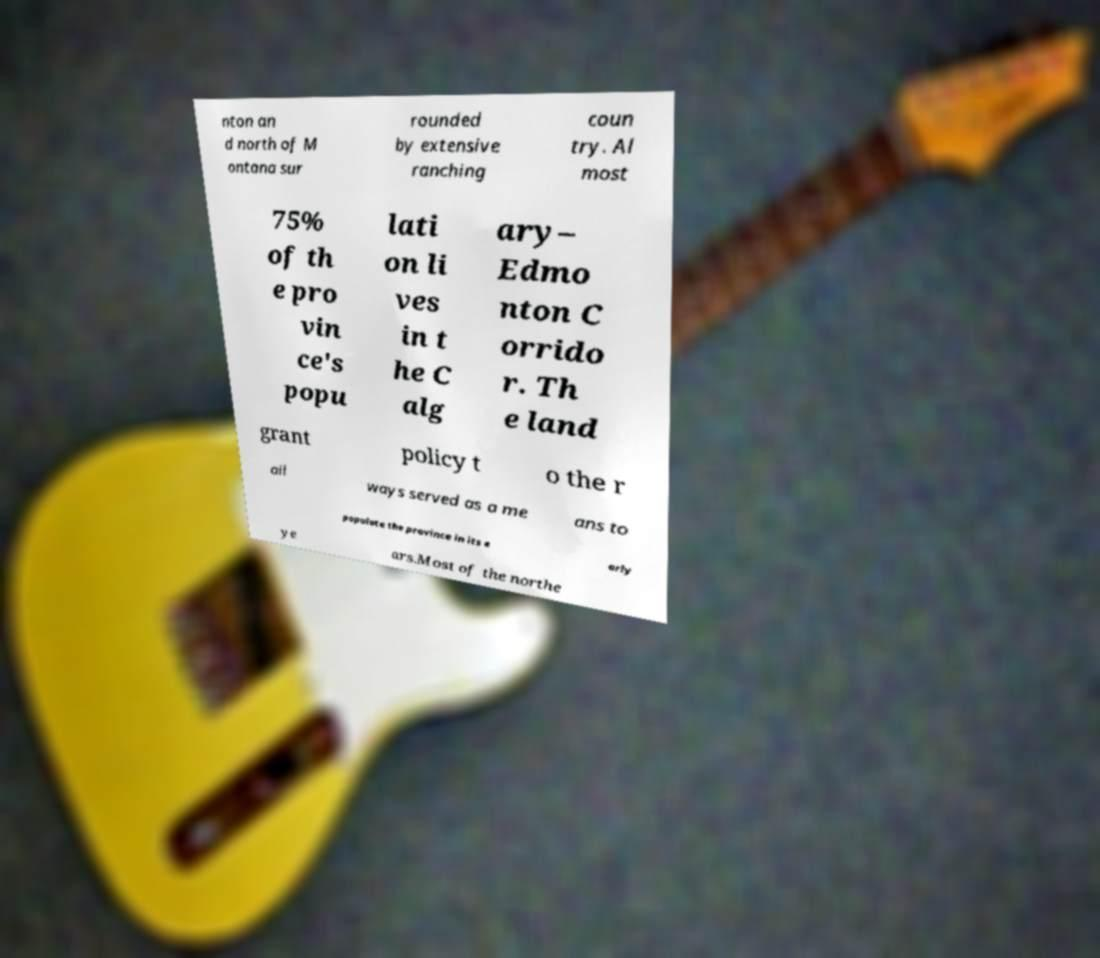For documentation purposes, I need the text within this image transcribed. Could you provide that? nton an d north of M ontana sur rounded by extensive ranching coun try. Al most 75% of th e pro vin ce's popu lati on li ves in t he C alg ary– Edmo nton C orrido r. Th e land grant policy t o the r ail ways served as a me ans to populate the province in its e arly ye ars.Most of the northe 